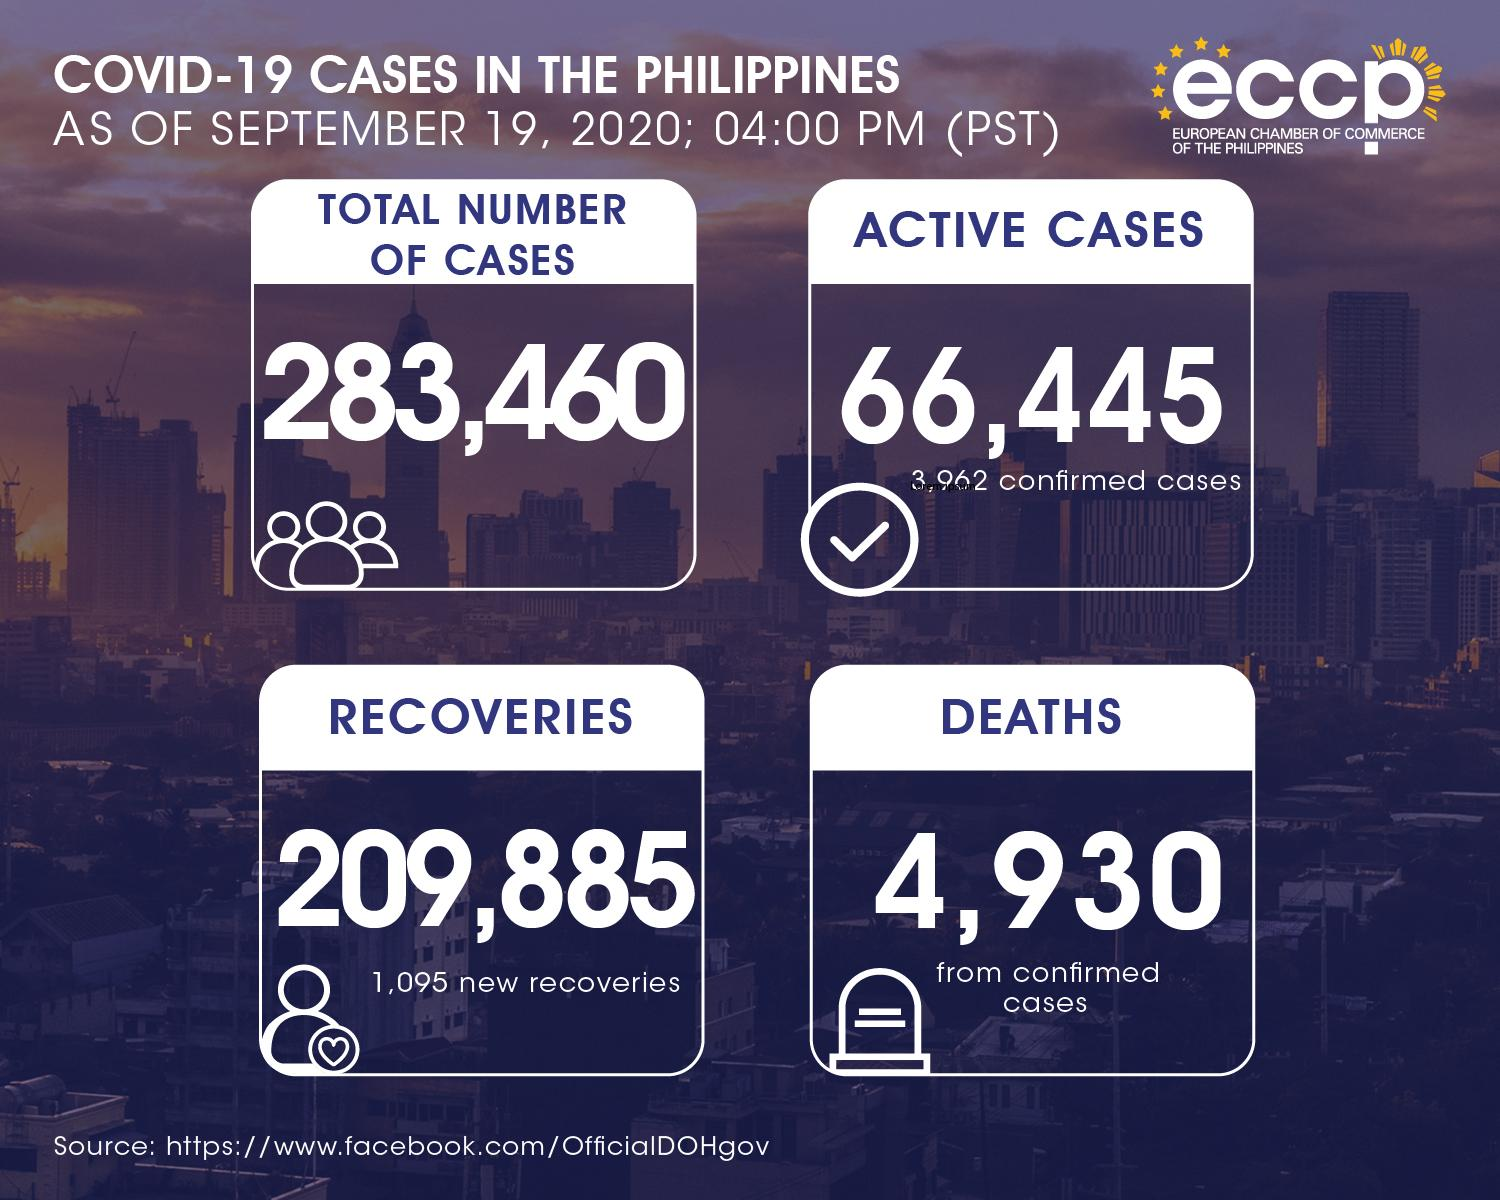Draw attention to some important aspects in this diagram. As of September 19, 2020, the total number of active COVID-19 cases in the Philippines was 66,445. As of September 19, 2020, the total number of COVID-19 cases in the Philippines was 283,460. As of September 19, 2020, the total number of COVID-19 deaths in the Philippines was 4,930. As of September 19, 2020, there have been 1,095 new recoveries from COVID-19 in the Philippines. 